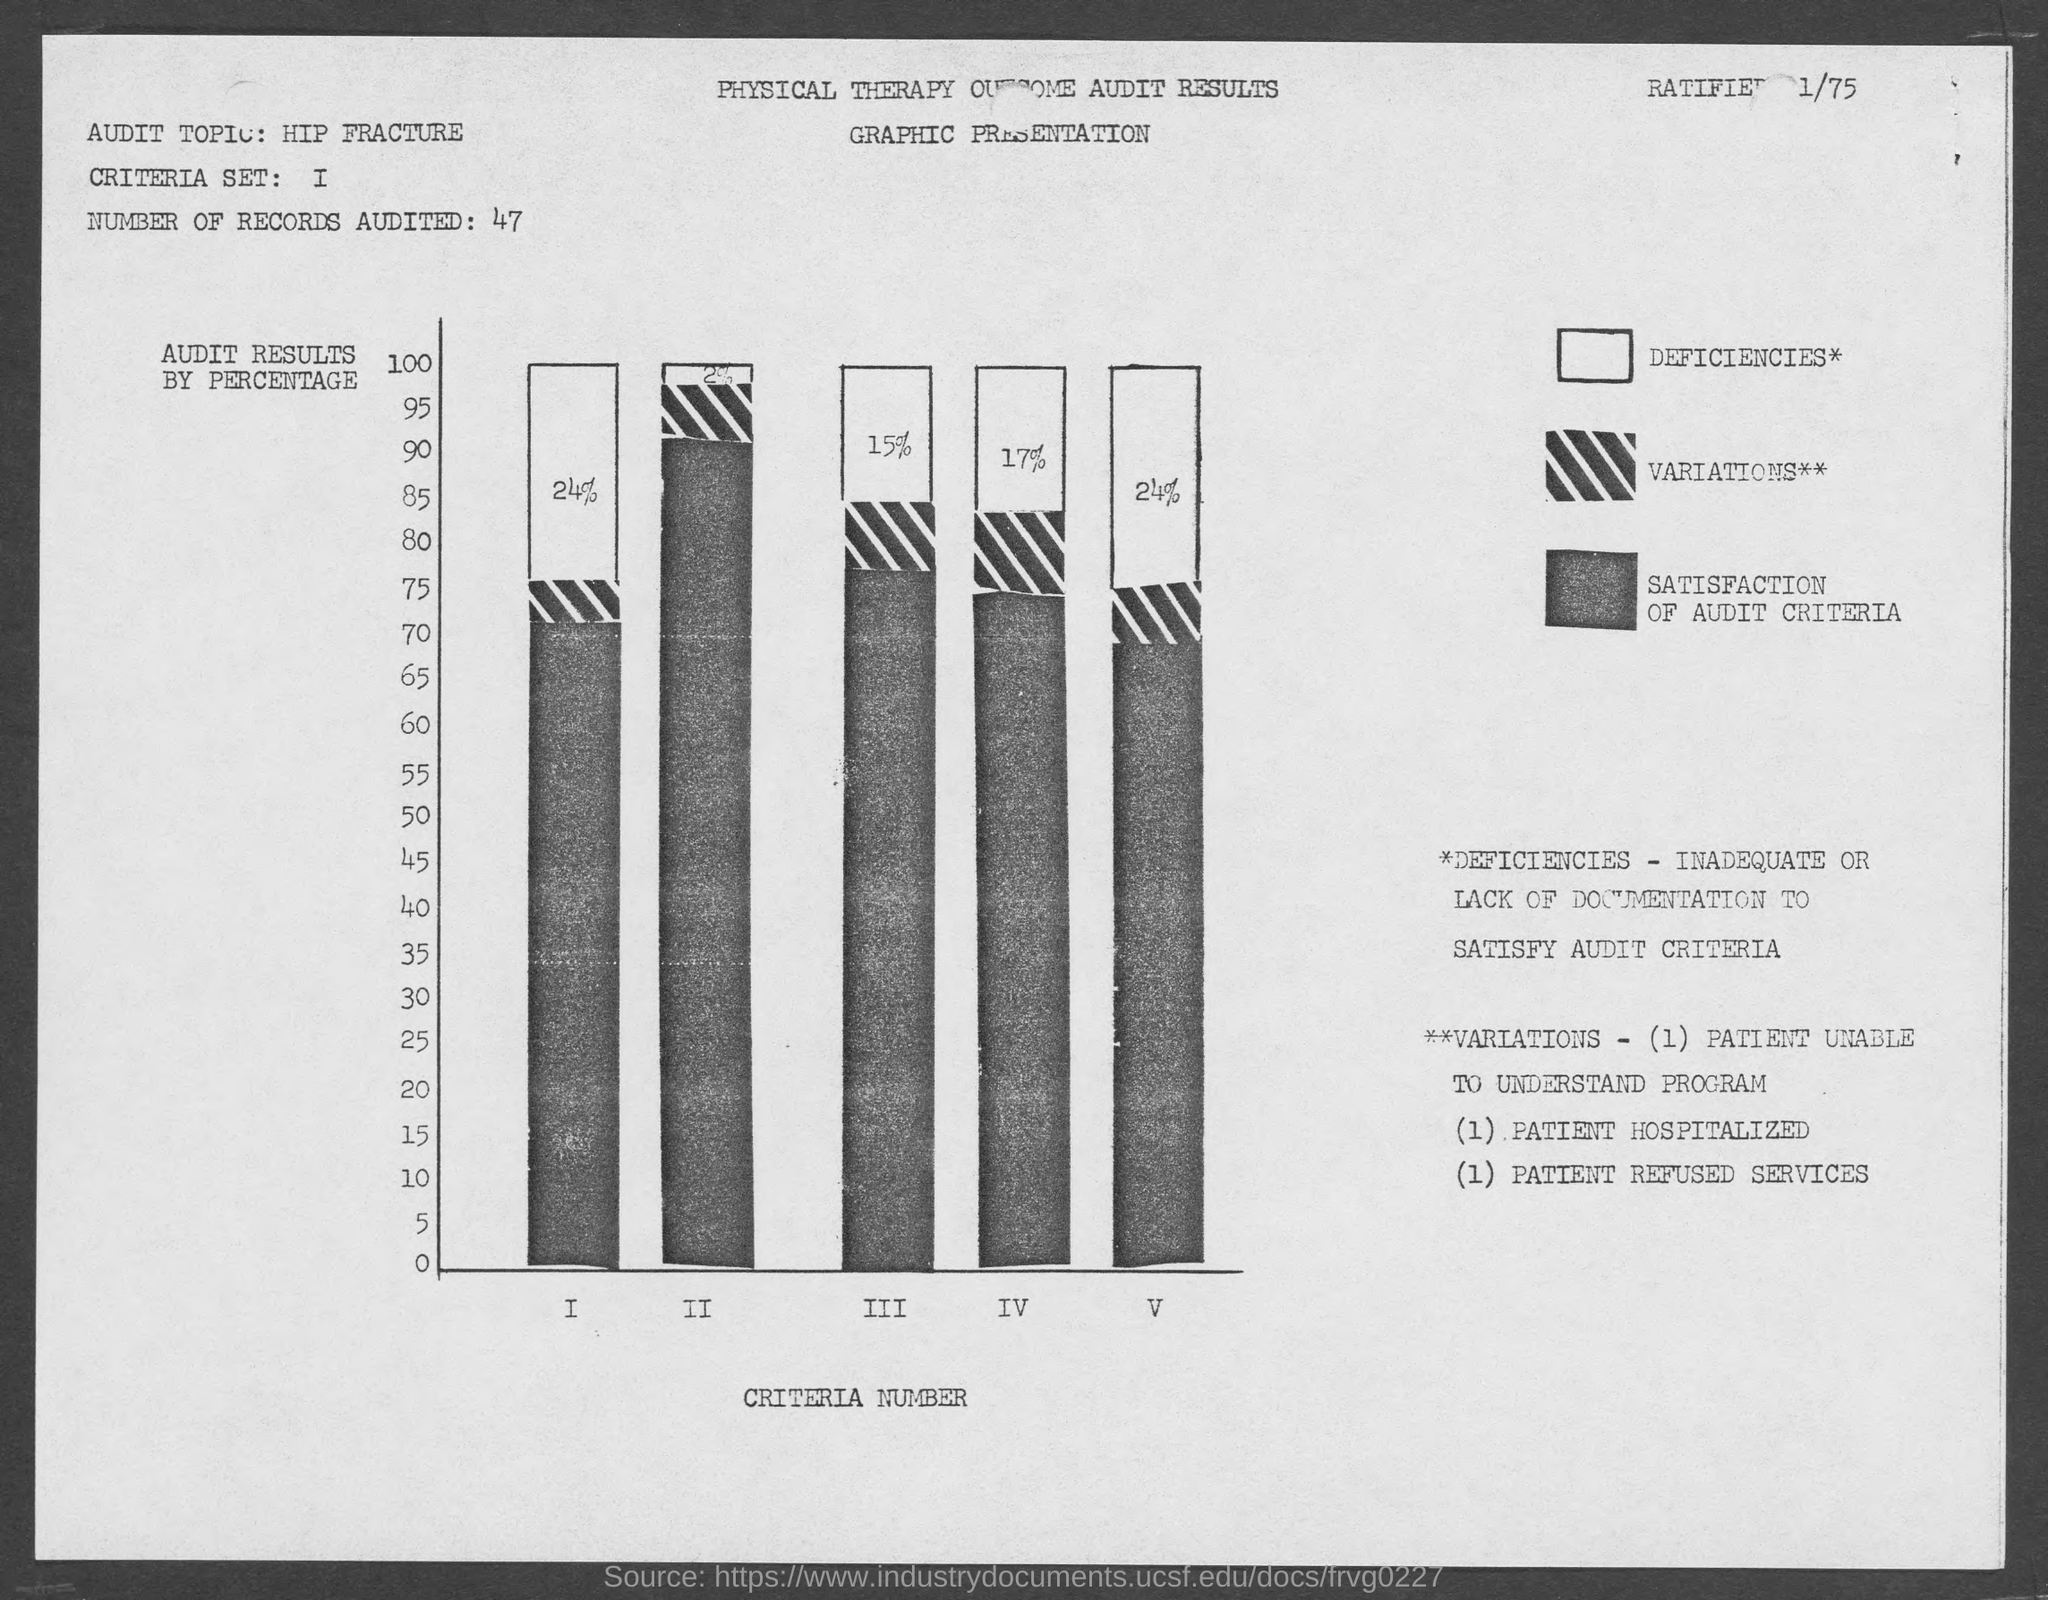Outline some significant characteristics in this image. The criteria that represents the x-axis of a graph is the variable that is used to mark the horizontal position or the horizontal position of the data points on the graph. The audit topic is hip fracture. The Y-axis of the graph represents the audit results, with the label 'Audit Results by Percentage.' The number of records audited is 47... 